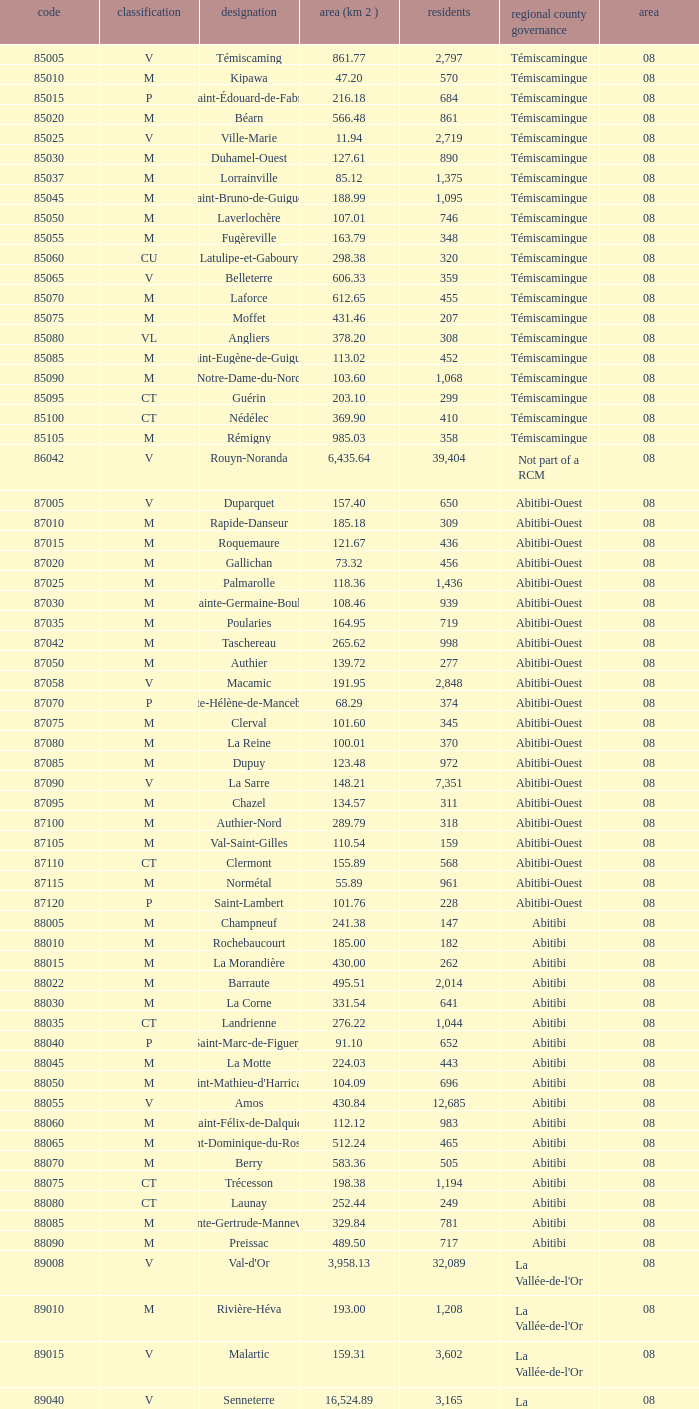What type has a population of 370? M. 